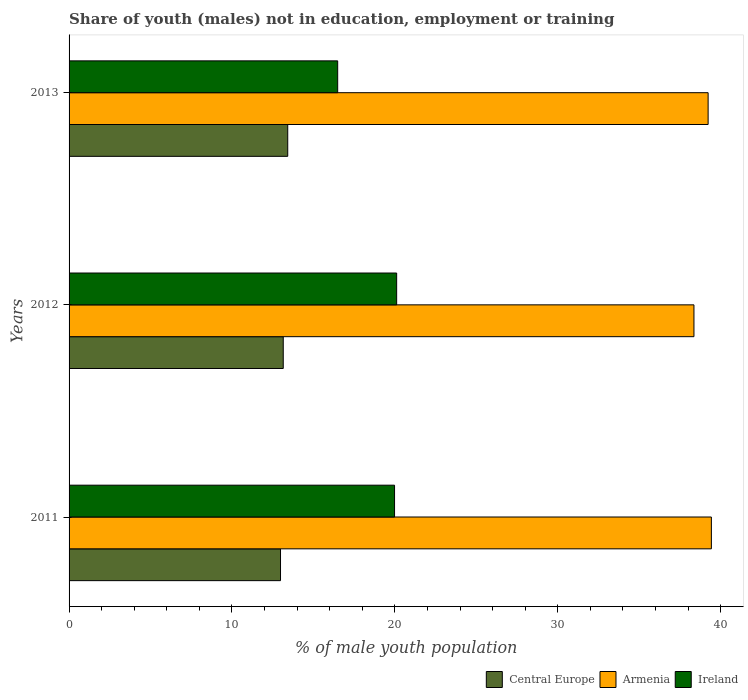How many different coloured bars are there?
Your response must be concise. 3. How many groups of bars are there?
Offer a terse response. 3. How many bars are there on the 2nd tick from the bottom?
Your response must be concise. 3. What is the percentage of unemployed males population in in Central Europe in 2013?
Offer a terse response. 13.42. Across all years, what is the maximum percentage of unemployed males population in in Ireland?
Make the answer very short. 20.11. Across all years, what is the minimum percentage of unemployed males population in in Central Europe?
Offer a terse response. 12.98. In which year was the percentage of unemployed males population in in Central Europe maximum?
Give a very brief answer. 2013. What is the total percentage of unemployed males population in in Central Europe in the graph?
Provide a short and direct response. 39.55. What is the difference between the percentage of unemployed males population in in Armenia in 2011 and that in 2012?
Ensure brevity in your answer.  1.07. What is the difference between the percentage of unemployed males population in in Ireland in 2011 and the percentage of unemployed males population in in Armenia in 2013?
Ensure brevity in your answer.  -19.25. What is the average percentage of unemployed males population in in Armenia per year?
Give a very brief answer. 39.01. In the year 2011, what is the difference between the percentage of unemployed males population in in Ireland and percentage of unemployed males population in in Central Europe?
Offer a terse response. 7. In how many years, is the percentage of unemployed males population in in Ireland greater than 34 %?
Offer a terse response. 0. What is the ratio of the percentage of unemployed males population in in Armenia in 2011 to that in 2013?
Your answer should be very brief. 1.01. Is the percentage of unemployed males population in in Armenia in 2011 less than that in 2013?
Give a very brief answer. No. What is the difference between the highest and the second highest percentage of unemployed males population in in Armenia?
Keep it short and to the point. 0.2. What is the difference between the highest and the lowest percentage of unemployed males population in in Armenia?
Make the answer very short. 1.07. What does the 3rd bar from the top in 2011 represents?
Your response must be concise. Central Europe. What does the 1st bar from the bottom in 2011 represents?
Your response must be concise. Central Europe. Are all the bars in the graph horizontal?
Ensure brevity in your answer.  Yes. How many years are there in the graph?
Your response must be concise. 3. What is the difference between two consecutive major ticks on the X-axis?
Offer a very short reply. 10. Does the graph contain any zero values?
Your answer should be very brief. No. Does the graph contain grids?
Provide a succinct answer. No. How are the legend labels stacked?
Keep it short and to the point. Horizontal. What is the title of the graph?
Provide a short and direct response. Share of youth (males) not in education, employment or training. Does "Malaysia" appear as one of the legend labels in the graph?
Give a very brief answer. No. What is the label or title of the X-axis?
Offer a terse response. % of male youth population. What is the label or title of the Y-axis?
Offer a terse response. Years. What is the % of male youth population of Central Europe in 2011?
Offer a very short reply. 12.98. What is the % of male youth population in Armenia in 2011?
Keep it short and to the point. 39.43. What is the % of male youth population in Ireland in 2011?
Your answer should be very brief. 19.98. What is the % of male youth population in Central Europe in 2012?
Your response must be concise. 13.15. What is the % of male youth population in Armenia in 2012?
Offer a terse response. 38.36. What is the % of male youth population of Ireland in 2012?
Offer a terse response. 20.11. What is the % of male youth population in Central Europe in 2013?
Your answer should be very brief. 13.42. What is the % of male youth population of Armenia in 2013?
Provide a succinct answer. 39.23. What is the % of male youth population in Ireland in 2013?
Offer a terse response. 16.49. Across all years, what is the maximum % of male youth population in Central Europe?
Your response must be concise. 13.42. Across all years, what is the maximum % of male youth population of Armenia?
Your answer should be very brief. 39.43. Across all years, what is the maximum % of male youth population in Ireland?
Keep it short and to the point. 20.11. Across all years, what is the minimum % of male youth population in Central Europe?
Provide a succinct answer. 12.98. Across all years, what is the minimum % of male youth population of Armenia?
Provide a short and direct response. 38.36. Across all years, what is the minimum % of male youth population of Ireland?
Make the answer very short. 16.49. What is the total % of male youth population of Central Europe in the graph?
Provide a succinct answer. 39.55. What is the total % of male youth population in Armenia in the graph?
Your answer should be compact. 117.02. What is the total % of male youth population in Ireland in the graph?
Offer a very short reply. 56.58. What is the difference between the % of male youth population of Central Europe in 2011 and that in 2012?
Offer a very short reply. -0.17. What is the difference between the % of male youth population of Armenia in 2011 and that in 2012?
Offer a very short reply. 1.07. What is the difference between the % of male youth population in Ireland in 2011 and that in 2012?
Make the answer very short. -0.13. What is the difference between the % of male youth population of Central Europe in 2011 and that in 2013?
Give a very brief answer. -0.44. What is the difference between the % of male youth population in Ireland in 2011 and that in 2013?
Give a very brief answer. 3.49. What is the difference between the % of male youth population in Central Europe in 2012 and that in 2013?
Provide a short and direct response. -0.28. What is the difference between the % of male youth population in Armenia in 2012 and that in 2013?
Offer a terse response. -0.87. What is the difference between the % of male youth population of Ireland in 2012 and that in 2013?
Provide a succinct answer. 3.62. What is the difference between the % of male youth population of Central Europe in 2011 and the % of male youth population of Armenia in 2012?
Provide a short and direct response. -25.38. What is the difference between the % of male youth population in Central Europe in 2011 and the % of male youth population in Ireland in 2012?
Your answer should be compact. -7.13. What is the difference between the % of male youth population in Armenia in 2011 and the % of male youth population in Ireland in 2012?
Offer a very short reply. 19.32. What is the difference between the % of male youth population of Central Europe in 2011 and the % of male youth population of Armenia in 2013?
Your answer should be very brief. -26.25. What is the difference between the % of male youth population in Central Europe in 2011 and the % of male youth population in Ireland in 2013?
Make the answer very short. -3.51. What is the difference between the % of male youth population of Armenia in 2011 and the % of male youth population of Ireland in 2013?
Provide a succinct answer. 22.94. What is the difference between the % of male youth population of Central Europe in 2012 and the % of male youth population of Armenia in 2013?
Your answer should be very brief. -26.08. What is the difference between the % of male youth population in Central Europe in 2012 and the % of male youth population in Ireland in 2013?
Give a very brief answer. -3.34. What is the difference between the % of male youth population in Armenia in 2012 and the % of male youth population in Ireland in 2013?
Keep it short and to the point. 21.87. What is the average % of male youth population in Central Europe per year?
Provide a succinct answer. 13.18. What is the average % of male youth population of Armenia per year?
Offer a terse response. 39.01. What is the average % of male youth population of Ireland per year?
Your answer should be compact. 18.86. In the year 2011, what is the difference between the % of male youth population of Central Europe and % of male youth population of Armenia?
Provide a short and direct response. -26.45. In the year 2011, what is the difference between the % of male youth population in Central Europe and % of male youth population in Ireland?
Ensure brevity in your answer.  -7. In the year 2011, what is the difference between the % of male youth population of Armenia and % of male youth population of Ireland?
Your answer should be very brief. 19.45. In the year 2012, what is the difference between the % of male youth population of Central Europe and % of male youth population of Armenia?
Ensure brevity in your answer.  -25.21. In the year 2012, what is the difference between the % of male youth population in Central Europe and % of male youth population in Ireland?
Keep it short and to the point. -6.96. In the year 2012, what is the difference between the % of male youth population in Armenia and % of male youth population in Ireland?
Your answer should be compact. 18.25. In the year 2013, what is the difference between the % of male youth population in Central Europe and % of male youth population in Armenia?
Your response must be concise. -25.81. In the year 2013, what is the difference between the % of male youth population of Central Europe and % of male youth population of Ireland?
Make the answer very short. -3.07. In the year 2013, what is the difference between the % of male youth population in Armenia and % of male youth population in Ireland?
Your response must be concise. 22.74. What is the ratio of the % of male youth population of Central Europe in 2011 to that in 2012?
Offer a very short reply. 0.99. What is the ratio of the % of male youth population in Armenia in 2011 to that in 2012?
Provide a succinct answer. 1.03. What is the ratio of the % of male youth population of Armenia in 2011 to that in 2013?
Provide a short and direct response. 1.01. What is the ratio of the % of male youth population in Ireland in 2011 to that in 2013?
Provide a succinct answer. 1.21. What is the ratio of the % of male youth population in Central Europe in 2012 to that in 2013?
Your response must be concise. 0.98. What is the ratio of the % of male youth population in Armenia in 2012 to that in 2013?
Give a very brief answer. 0.98. What is the ratio of the % of male youth population in Ireland in 2012 to that in 2013?
Your answer should be compact. 1.22. What is the difference between the highest and the second highest % of male youth population of Central Europe?
Give a very brief answer. 0.28. What is the difference between the highest and the second highest % of male youth population of Ireland?
Ensure brevity in your answer.  0.13. What is the difference between the highest and the lowest % of male youth population in Central Europe?
Your response must be concise. 0.44. What is the difference between the highest and the lowest % of male youth population of Armenia?
Offer a terse response. 1.07. What is the difference between the highest and the lowest % of male youth population of Ireland?
Your answer should be very brief. 3.62. 